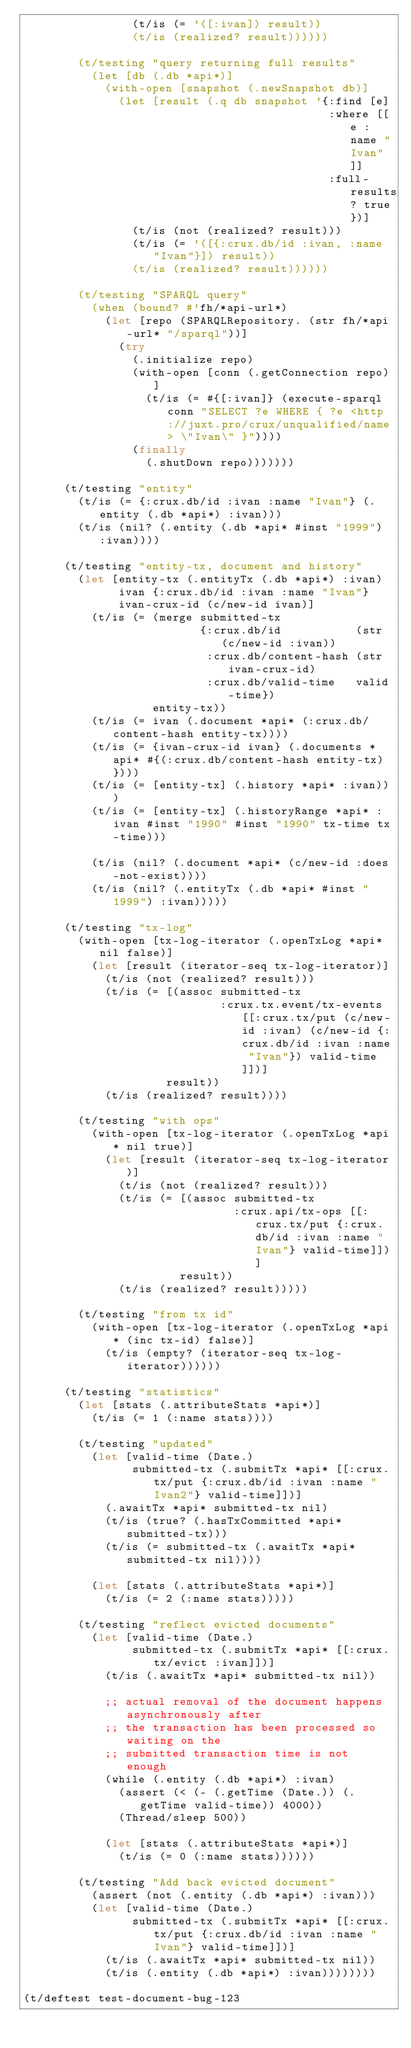Convert code to text. <code><loc_0><loc_0><loc_500><loc_500><_Clojure_>                (t/is (= '([:ivan]) result))
                (t/is (realized? result))))))

        (t/testing "query returning full results"
          (let [db (.db *api*)]
            (with-open [snapshot (.newSnapshot db)]
              (let [result (.q db snapshot '{:find [e]
                                             :where [[e :name "Ivan"]]
                                             :full-results? true})]
                (t/is (not (realized? result)))
                (t/is (= '([{:crux.db/id :ivan, :name "Ivan"}]) result))
                (t/is (realized? result))))))

        (t/testing "SPARQL query"
          (when (bound? #'fh/*api-url*)
            (let [repo (SPARQLRepository. (str fh/*api-url* "/sparql"))]
              (try
                (.initialize repo)
                (with-open [conn (.getConnection repo)]
                  (t/is (= #{[:ivan]} (execute-sparql conn "SELECT ?e WHERE { ?e <http://juxt.pro/crux/unqualified/name> \"Ivan\" }"))))
                (finally
                  (.shutDown repo)))))))

      (t/testing "entity"
        (t/is (= {:crux.db/id :ivan :name "Ivan"} (.entity (.db *api*) :ivan)))
        (t/is (nil? (.entity (.db *api* #inst "1999") :ivan))))

      (t/testing "entity-tx, document and history"
        (let [entity-tx (.entityTx (.db *api*) :ivan)
              ivan {:crux.db/id :ivan :name "Ivan"}
              ivan-crux-id (c/new-id ivan)]
          (t/is (= (merge submitted-tx
                          {:crux.db/id           (str (c/new-id :ivan))
                           :crux.db/content-hash (str ivan-crux-id)
                           :crux.db/valid-time   valid-time})
                   entity-tx))
          (t/is (= ivan (.document *api* (:crux.db/content-hash entity-tx))))
          (t/is (= {ivan-crux-id ivan} (.documents *api* #{(:crux.db/content-hash entity-tx)})))
          (t/is (= [entity-tx] (.history *api* :ivan)))
          (t/is (= [entity-tx] (.historyRange *api* :ivan #inst "1990" #inst "1990" tx-time tx-time)))

          (t/is (nil? (.document *api* (c/new-id :does-not-exist))))
          (t/is (nil? (.entityTx (.db *api* #inst "1999") :ivan)))))

      (t/testing "tx-log"
        (with-open [tx-log-iterator (.openTxLog *api* nil false)]
          (let [result (iterator-seq tx-log-iterator)]
            (t/is (not (realized? result)))
            (t/is (= [(assoc submitted-tx
                             :crux.tx.event/tx-events [[:crux.tx/put (c/new-id :ivan) (c/new-id {:crux.db/id :ivan :name "Ivan"}) valid-time]])]
                     result))
            (t/is (realized? result))))

        (t/testing "with ops"
          (with-open [tx-log-iterator (.openTxLog *api* nil true)]
            (let [result (iterator-seq tx-log-iterator)]
              (t/is (not (realized? result)))
              (t/is (= [(assoc submitted-tx
                               :crux.api/tx-ops [[:crux.tx/put {:crux.db/id :ivan :name "Ivan"} valid-time]])]
                       result))
              (t/is (realized? result)))))

        (t/testing "from tx id"
          (with-open [tx-log-iterator (.openTxLog *api* (inc tx-id) false)]
            (t/is (empty? (iterator-seq tx-log-iterator))))))

      (t/testing "statistics"
        (let [stats (.attributeStats *api*)]
          (t/is (= 1 (:name stats))))

        (t/testing "updated"
          (let [valid-time (Date.)
                submitted-tx (.submitTx *api* [[:crux.tx/put {:crux.db/id :ivan :name "Ivan2"} valid-time]])]
            (.awaitTx *api* submitted-tx nil)
            (t/is (true? (.hasTxCommitted *api* submitted-tx)))
            (t/is (= submitted-tx (.awaitTx *api* submitted-tx nil))))

          (let [stats (.attributeStats *api*)]
            (t/is (= 2 (:name stats)))))

        (t/testing "reflect evicted documents"
          (let [valid-time (Date.)
                submitted-tx (.submitTx *api* [[:crux.tx/evict :ivan]])]
            (t/is (.awaitTx *api* submitted-tx nil))

            ;; actual removal of the document happens asynchronously after
            ;; the transaction has been processed so waiting on the
            ;; submitted transaction time is not enough
            (while (.entity (.db *api*) :ivan)
              (assert (< (- (.getTime (Date.)) (.getTime valid-time)) 4000))
              (Thread/sleep 500))

            (let [stats (.attributeStats *api*)]
              (t/is (= 0 (:name stats))))))

        (t/testing "Add back evicted document"
          (assert (not (.entity (.db *api*) :ivan)))
          (let [valid-time (Date.)
                submitted-tx (.submitTx *api* [[:crux.tx/put {:crux.db/id :ivan :name "Ivan"} valid-time]])]
            (t/is (.awaitTx *api* submitted-tx nil))
            (t/is (.entity (.db *api*) :ivan))))))))

(t/deftest test-document-bug-123</code> 